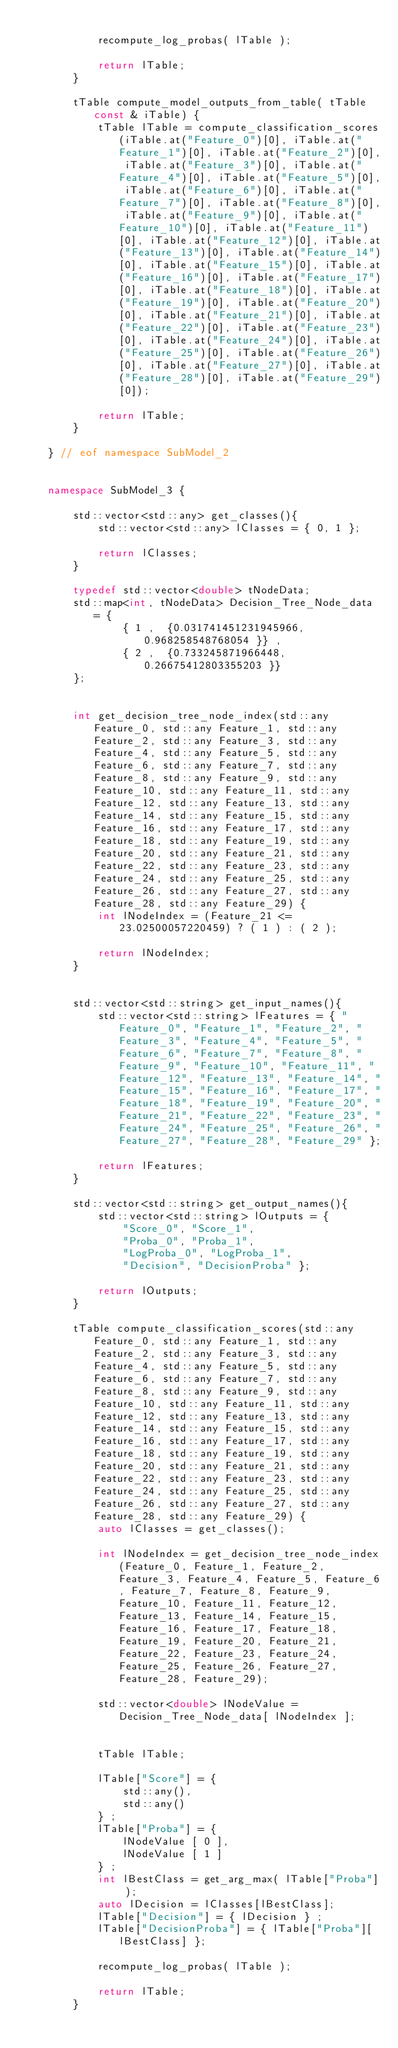Convert code to text. <code><loc_0><loc_0><loc_500><loc_500><_C++_>	
			recompute_log_probas( lTable );
	
			return lTable;
		}
	
		tTable compute_model_outputs_from_table( tTable const & iTable) {
			tTable lTable = compute_classification_scores(iTable.at("Feature_0")[0], iTable.at("Feature_1")[0], iTable.at("Feature_2")[0], iTable.at("Feature_3")[0], iTable.at("Feature_4")[0], iTable.at("Feature_5")[0], iTable.at("Feature_6")[0], iTable.at("Feature_7")[0], iTable.at("Feature_8")[0], iTable.at("Feature_9")[0], iTable.at("Feature_10")[0], iTable.at("Feature_11")[0], iTable.at("Feature_12")[0], iTable.at("Feature_13")[0], iTable.at("Feature_14")[0], iTable.at("Feature_15")[0], iTable.at("Feature_16")[0], iTable.at("Feature_17")[0], iTable.at("Feature_18")[0], iTable.at("Feature_19")[0], iTable.at("Feature_20")[0], iTable.at("Feature_21")[0], iTable.at("Feature_22")[0], iTable.at("Feature_23")[0], iTable.at("Feature_24")[0], iTable.at("Feature_25")[0], iTable.at("Feature_26")[0], iTable.at("Feature_27")[0], iTable.at("Feature_28")[0], iTable.at("Feature_29")[0]);
	
			return lTable;
		}
	
	} // eof namespace SubModel_2
	

	namespace SubModel_3 {
	
		std::vector<std::any> get_classes(){
			std::vector<std::any> lClasses = { 0, 1 };
	
			return lClasses;
		}
	
		typedef std::vector<double> tNodeData;
		std::map<int, tNodeData> Decision_Tree_Node_data = {
				{ 1 ,  {0.031741451231945966, 0.968258548768054 }} ,
				{ 2 ,  {0.733245871966448, 0.26675412803355203 }} 
		};
		
	
		int get_decision_tree_node_index(std::any Feature_0, std::any Feature_1, std::any Feature_2, std::any Feature_3, std::any Feature_4, std::any Feature_5, std::any Feature_6, std::any Feature_7, std::any Feature_8, std::any Feature_9, std::any Feature_10, std::any Feature_11, std::any Feature_12, std::any Feature_13, std::any Feature_14, std::any Feature_15, std::any Feature_16, std::any Feature_17, std::any Feature_18, std::any Feature_19, std::any Feature_20, std::any Feature_21, std::any Feature_22, std::any Feature_23, std::any Feature_24, std::any Feature_25, std::any Feature_26, std::any Feature_27, std::any Feature_28, std::any Feature_29) {
			int lNodeIndex = (Feature_21 <= 23.02500057220459) ? ( 1 ) : ( 2 );
		
			return lNodeIndex;
		}
		
	
		std::vector<std::string> get_input_names(){
			std::vector<std::string> lFeatures = { "Feature_0", "Feature_1", "Feature_2", "Feature_3", "Feature_4", "Feature_5", "Feature_6", "Feature_7", "Feature_8", "Feature_9", "Feature_10", "Feature_11", "Feature_12", "Feature_13", "Feature_14", "Feature_15", "Feature_16", "Feature_17", "Feature_18", "Feature_19", "Feature_20", "Feature_21", "Feature_22", "Feature_23", "Feature_24", "Feature_25", "Feature_26", "Feature_27", "Feature_28", "Feature_29" };
	
			return lFeatures;
		}
	
		std::vector<std::string> get_output_names(){
			std::vector<std::string> lOutputs = { 
				"Score_0", "Score_1",
				"Proba_0", "Proba_1",
				"LogProba_0", "LogProba_1",
				"Decision", "DecisionProba" };
	
			return lOutputs;
		}
	
		tTable compute_classification_scores(std::any Feature_0, std::any Feature_1, std::any Feature_2, std::any Feature_3, std::any Feature_4, std::any Feature_5, std::any Feature_6, std::any Feature_7, std::any Feature_8, std::any Feature_9, std::any Feature_10, std::any Feature_11, std::any Feature_12, std::any Feature_13, std::any Feature_14, std::any Feature_15, std::any Feature_16, std::any Feature_17, std::any Feature_18, std::any Feature_19, std::any Feature_20, std::any Feature_21, std::any Feature_22, std::any Feature_23, std::any Feature_24, std::any Feature_25, std::any Feature_26, std::any Feature_27, std::any Feature_28, std::any Feature_29) {
			auto lClasses = get_classes();
	
			int lNodeIndex = get_decision_tree_node_index(Feature_0, Feature_1, Feature_2, Feature_3, Feature_4, Feature_5, Feature_6, Feature_7, Feature_8, Feature_9, Feature_10, Feature_11, Feature_12, Feature_13, Feature_14, Feature_15, Feature_16, Feature_17, Feature_18, Feature_19, Feature_20, Feature_21, Feature_22, Feature_23, Feature_24, Feature_25, Feature_26, Feature_27, Feature_28, Feature_29);
	
			std::vector<double> lNodeValue = Decision_Tree_Node_data[ lNodeIndex ];
	
	
			tTable lTable;
	
			lTable["Score"] = { 
				std::any(),
				std::any() 
			} ;
			lTable["Proba"] = { 
				lNodeValue [ 0 ],
				lNodeValue [ 1 ] 
			} ;
			int lBestClass = get_arg_max( lTable["Proba"] );
			auto lDecision = lClasses[lBestClass];
			lTable["Decision"] = { lDecision } ;
			lTable["DecisionProba"] = { lTable["Proba"][lBestClass] };
	
			recompute_log_probas( lTable );
	
			return lTable;
		}
	</code> 